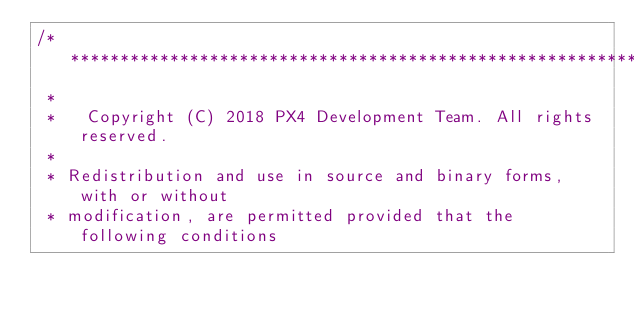<code> <loc_0><loc_0><loc_500><loc_500><_C++_>/****************************************************************************
 *
 *   Copyright (C) 2018 PX4 Development Team. All rights reserved.
 *
 * Redistribution and use in source and binary forms, with or without
 * modification, are permitted provided that the following conditions</code> 